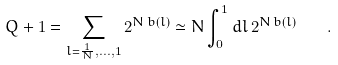Convert formula to latex. <formula><loc_0><loc_0><loc_500><loc_500>Q + 1 = \sum _ { l = \frac { 1 } { N } , \dots , 1 } 2 ^ { N \, b ( l ) } \simeq N \int _ { 0 } ^ { 1 } d l \, 2 ^ { N \, b ( l ) } \quad .</formula> 